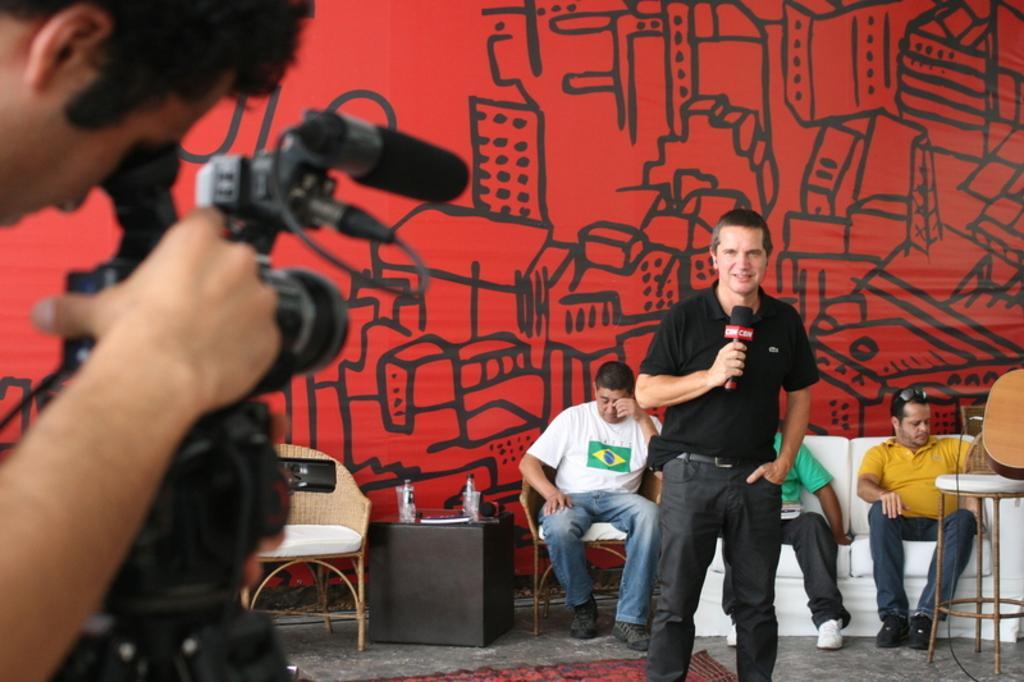Describe this image in one or two sentences. In this image in the middle one man is standing. He is wearing black dress and holding one mic. He is looking at the camera in front of him. On the left side a man is holding one camera. Behind the middle man there is one sofa and a chair. On that three people are sitting. Beside him there is a table. Another table on his right hand side. On the table there is bottle glasses. On the background there is a wallpaper which is red in color. 